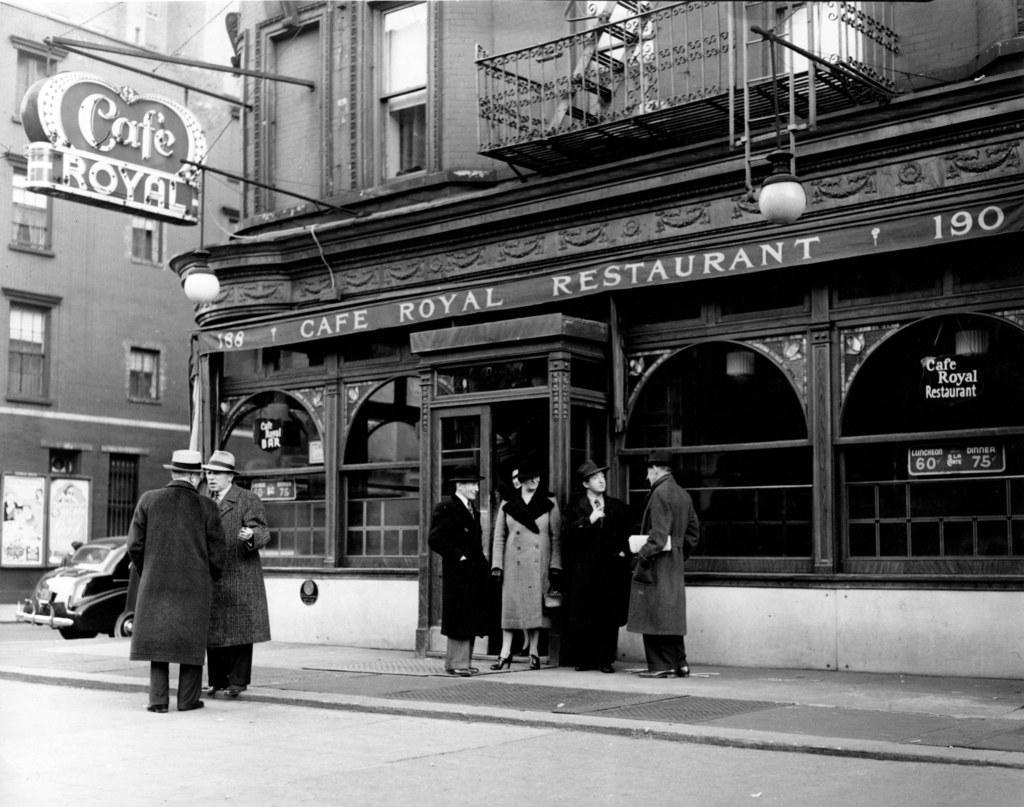In one or two sentences, can you explain what this image depicts? In the picture we can see a black and white photograph of a restaurant building and near it we can see four people are standing and talking to each other and just beside them we can see a road on it we can see two men are standing and talking to each other and they are in hats and beside the building we can see a car is parked and beside it we can see another building with windows to it and a name on it as royal cafe. 